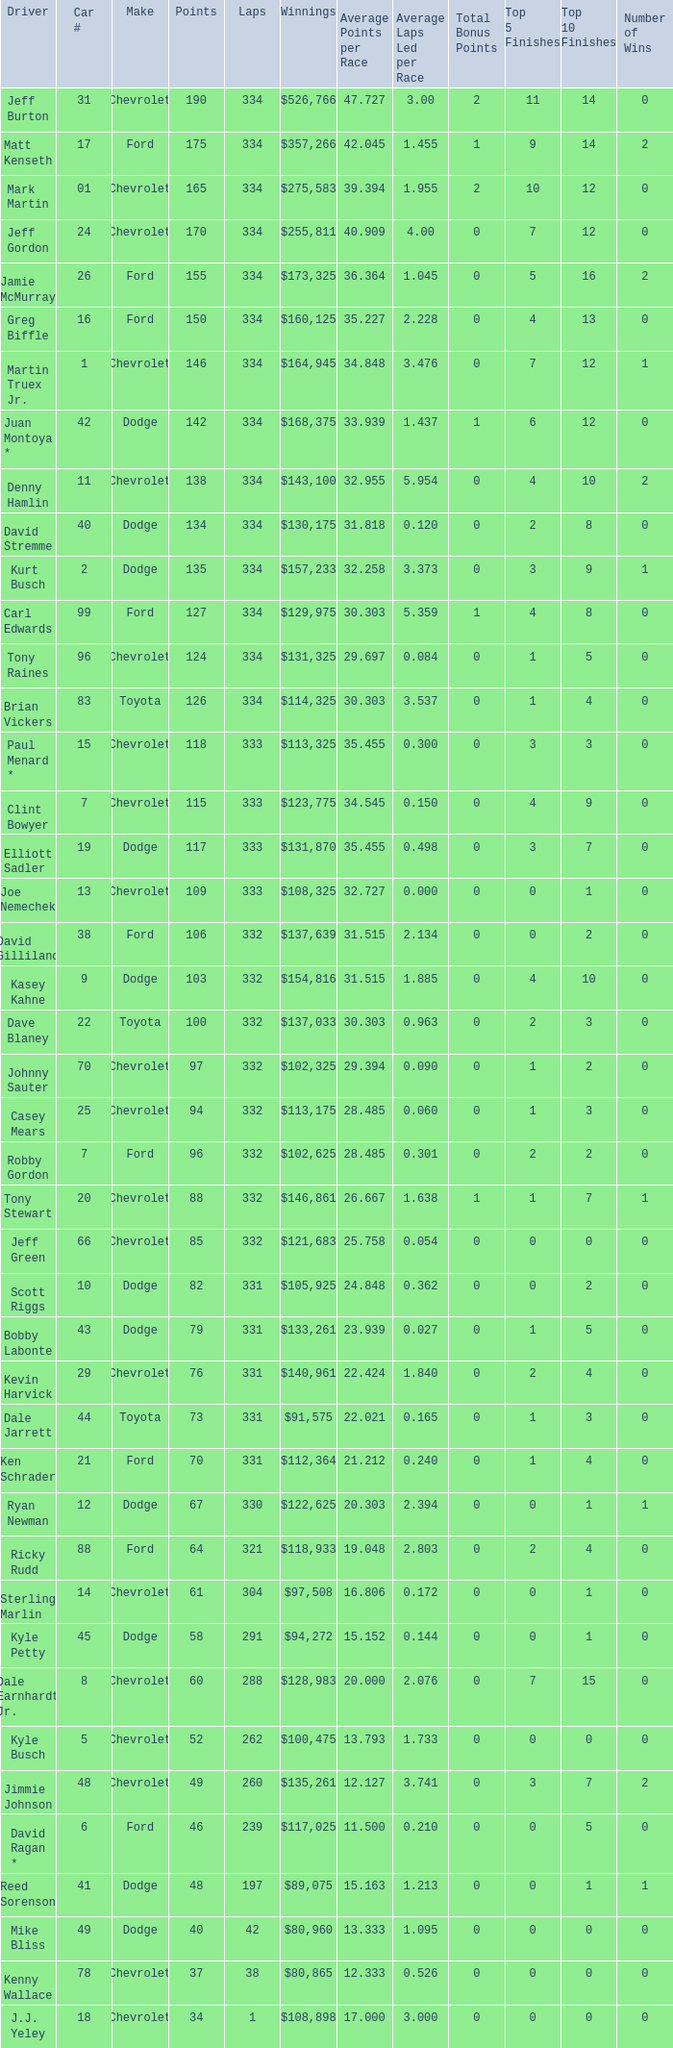How many total laps did the Chevrolet that won $97,508 make? 1.0. 